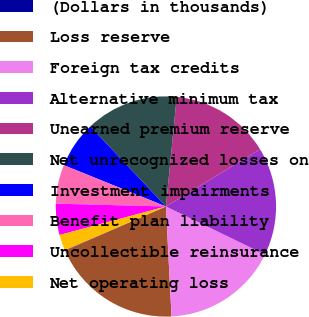Convert chart. <chart><loc_0><loc_0><loc_500><loc_500><pie_chart><fcel>(Dollars in thousands)<fcel>Loss reserve<fcel>Foreign tax credits<fcel>Alternative minimum tax<fcel>Unearned premium reserve<fcel>Net unrecognized losses on<fcel>Investment impairments<fcel>Benefit plan liability<fcel>Uncollectible reinsurance<fcel>Net operating loss<nl><fcel>0.06%<fcel>19.27%<fcel>17.01%<fcel>15.88%<fcel>14.75%<fcel>13.62%<fcel>6.84%<fcel>5.71%<fcel>4.58%<fcel>2.32%<nl></chart> 